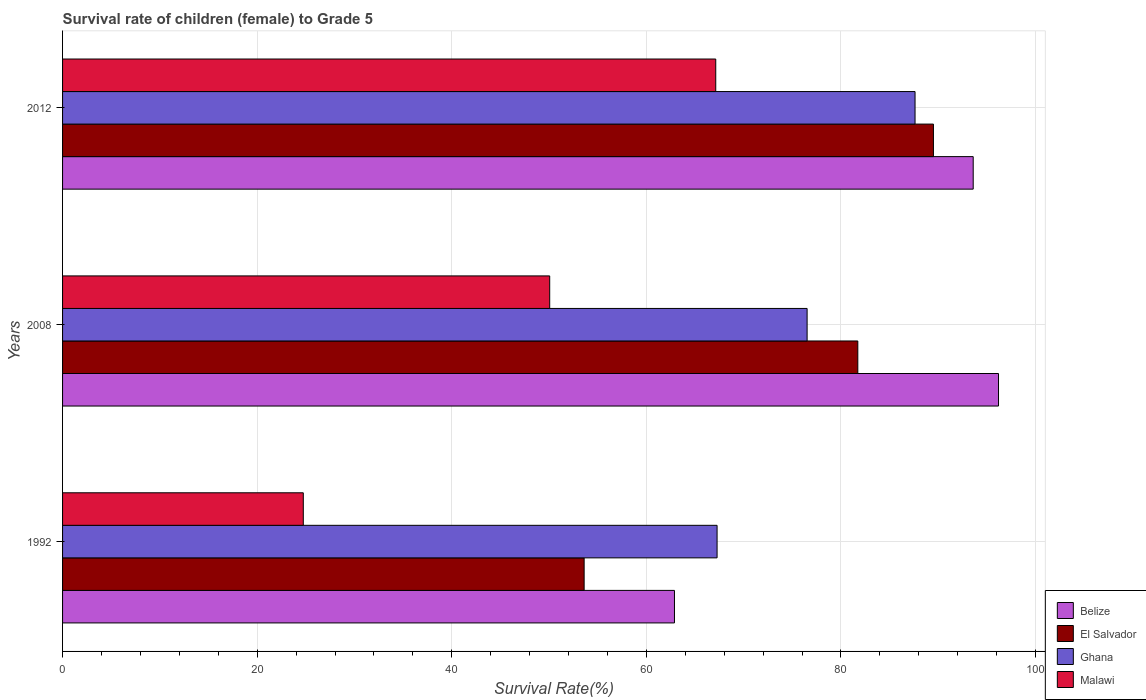How many groups of bars are there?
Your answer should be very brief. 3. In how many cases, is the number of bars for a given year not equal to the number of legend labels?
Make the answer very short. 0. What is the survival rate of female children to grade 5 in El Salvador in 2012?
Make the answer very short. 89.5. Across all years, what is the maximum survival rate of female children to grade 5 in Belize?
Your answer should be compact. 96.19. Across all years, what is the minimum survival rate of female children to grade 5 in Ghana?
Offer a very short reply. 67.27. In which year was the survival rate of female children to grade 5 in Malawi minimum?
Your response must be concise. 1992. What is the total survival rate of female children to grade 5 in El Salvador in the graph?
Offer a terse response. 224.84. What is the difference between the survival rate of female children to grade 5 in El Salvador in 1992 and that in 2008?
Provide a succinct answer. -28.13. What is the difference between the survival rate of female children to grade 5 in Belize in 2008 and the survival rate of female children to grade 5 in Malawi in 2012?
Your response must be concise. 29.06. What is the average survival rate of female children to grade 5 in Malawi per year?
Provide a short and direct response. 47.31. In the year 2012, what is the difference between the survival rate of female children to grade 5 in Ghana and survival rate of female children to grade 5 in Belize?
Provide a short and direct response. -5.98. In how many years, is the survival rate of female children to grade 5 in Belize greater than 80 %?
Your answer should be very brief. 2. What is the ratio of the survival rate of female children to grade 5 in El Salvador in 1992 to that in 2012?
Provide a succinct answer. 0.6. Is the survival rate of female children to grade 5 in El Salvador in 2008 less than that in 2012?
Provide a short and direct response. Yes. What is the difference between the highest and the second highest survival rate of female children to grade 5 in Belize?
Keep it short and to the point. 2.6. What is the difference between the highest and the lowest survival rate of female children to grade 5 in Ghana?
Give a very brief answer. 20.35. In how many years, is the survival rate of female children to grade 5 in Belize greater than the average survival rate of female children to grade 5 in Belize taken over all years?
Offer a terse response. 2. What does the 4th bar from the top in 2008 represents?
Give a very brief answer. Belize. What does the 4th bar from the bottom in 2012 represents?
Your response must be concise. Malawi. How many years are there in the graph?
Give a very brief answer. 3. Are the values on the major ticks of X-axis written in scientific E-notation?
Ensure brevity in your answer.  No. Where does the legend appear in the graph?
Offer a terse response. Bottom right. What is the title of the graph?
Your answer should be compact. Survival rate of children (female) to Grade 5. Does "Saudi Arabia" appear as one of the legend labels in the graph?
Make the answer very short. No. What is the label or title of the X-axis?
Your response must be concise. Survival Rate(%). What is the label or title of the Y-axis?
Your response must be concise. Years. What is the Survival Rate(%) in Belize in 1992?
Provide a succinct answer. 62.89. What is the Survival Rate(%) of El Salvador in 1992?
Give a very brief answer. 53.6. What is the Survival Rate(%) in Ghana in 1992?
Provide a succinct answer. 67.27. What is the Survival Rate(%) of Malawi in 1992?
Keep it short and to the point. 24.74. What is the Survival Rate(%) in Belize in 2008?
Your response must be concise. 96.19. What is the Survival Rate(%) in El Salvador in 2008?
Provide a short and direct response. 81.73. What is the Survival Rate(%) of Ghana in 2008?
Provide a short and direct response. 76.52. What is the Survival Rate(%) in Malawi in 2008?
Offer a very short reply. 50.07. What is the Survival Rate(%) of Belize in 2012?
Make the answer very short. 93.59. What is the Survival Rate(%) of El Salvador in 2012?
Your answer should be very brief. 89.5. What is the Survival Rate(%) in Ghana in 2012?
Your answer should be very brief. 87.61. What is the Survival Rate(%) in Malawi in 2012?
Your response must be concise. 67.13. Across all years, what is the maximum Survival Rate(%) in Belize?
Give a very brief answer. 96.19. Across all years, what is the maximum Survival Rate(%) of El Salvador?
Ensure brevity in your answer.  89.5. Across all years, what is the maximum Survival Rate(%) of Ghana?
Your response must be concise. 87.61. Across all years, what is the maximum Survival Rate(%) of Malawi?
Offer a terse response. 67.13. Across all years, what is the minimum Survival Rate(%) in Belize?
Give a very brief answer. 62.89. Across all years, what is the minimum Survival Rate(%) in El Salvador?
Provide a succinct answer. 53.6. Across all years, what is the minimum Survival Rate(%) of Ghana?
Your answer should be very brief. 67.27. Across all years, what is the minimum Survival Rate(%) of Malawi?
Your response must be concise. 24.74. What is the total Survival Rate(%) of Belize in the graph?
Ensure brevity in your answer.  252.67. What is the total Survival Rate(%) of El Salvador in the graph?
Make the answer very short. 224.84. What is the total Survival Rate(%) of Ghana in the graph?
Keep it short and to the point. 231.4. What is the total Survival Rate(%) of Malawi in the graph?
Your answer should be very brief. 141.94. What is the difference between the Survival Rate(%) of Belize in 1992 and that in 2008?
Ensure brevity in your answer.  -33.3. What is the difference between the Survival Rate(%) of El Salvador in 1992 and that in 2008?
Offer a very short reply. -28.13. What is the difference between the Survival Rate(%) of Ghana in 1992 and that in 2008?
Give a very brief answer. -9.25. What is the difference between the Survival Rate(%) in Malawi in 1992 and that in 2008?
Your response must be concise. -25.32. What is the difference between the Survival Rate(%) in Belize in 1992 and that in 2012?
Make the answer very short. -30.7. What is the difference between the Survival Rate(%) of El Salvador in 1992 and that in 2012?
Offer a terse response. -35.9. What is the difference between the Survival Rate(%) of Ghana in 1992 and that in 2012?
Keep it short and to the point. -20.35. What is the difference between the Survival Rate(%) in Malawi in 1992 and that in 2012?
Keep it short and to the point. -42.39. What is the difference between the Survival Rate(%) of Belize in 2008 and that in 2012?
Your response must be concise. 2.6. What is the difference between the Survival Rate(%) in El Salvador in 2008 and that in 2012?
Offer a terse response. -7.77. What is the difference between the Survival Rate(%) of Ghana in 2008 and that in 2012?
Keep it short and to the point. -11.09. What is the difference between the Survival Rate(%) in Malawi in 2008 and that in 2012?
Provide a short and direct response. -17.07. What is the difference between the Survival Rate(%) in Belize in 1992 and the Survival Rate(%) in El Salvador in 2008?
Offer a very short reply. -18.84. What is the difference between the Survival Rate(%) in Belize in 1992 and the Survival Rate(%) in Ghana in 2008?
Offer a very short reply. -13.63. What is the difference between the Survival Rate(%) in Belize in 1992 and the Survival Rate(%) in Malawi in 2008?
Provide a short and direct response. 12.82. What is the difference between the Survival Rate(%) in El Salvador in 1992 and the Survival Rate(%) in Ghana in 2008?
Your answer should be very brief. -22.92. What is the difference between the Survival Rate(%) in El Salvador in 1992 and the Survival Rate(%) in Malawi in 2008?
Your answer should be very brief. 3.54. What is the difference between the Survival Rate(%) in Ghana in 1992 and the Survival Rate(%) in Malawi in 2008?
Your response must be concise. 17.2. What is the difference between the Survival Rate(%) of Belize in 1992 and the Survival Rate(%) of El Salvador in 2012?
Your response must be concise. -26.61. What is the difference between the Survival Rate(%) in Belize in 1992 and the Survival Rate(%) in Ghana in 2012?
Provide a succinct answer. -24.72. What is the difference between the Survival Rate(%) of Belize in 1992 and the Survival Rate(%) of Malawi in 2012?
Offer a terse response. -4.24. What is the difference between the Survival Rate(%) of El Salvador in 1992 and the Survival Rate(%) of Ghana in 2012?
Offer a very short reply. -34.01. What is the difference between the Survival Rate(%) of El Salvador in 1992 and the Survival Rate(%) of Malawi in 2012?
Your answer should be very brief. -13.53. What is the difference between the Survival Rate(%) of Ghana in 1992 and the Survival Rate(%) of Malawi in 2012?
Ensure brevity in your answer.  0.14. What is the difference between the Survival Rate(%) of Belize in 2008 and the Survival Rate(%) of El Salvador in 2012?
Your answer should be very brief. 6.69. What is the difference between the Survival Rate(%) of Belize in 2008 and the Survival Rate(%) of Ghana in 2012?
Your answer should be very brief. 8.58. What is the difference between the Survival Rate(%) of Belize in 2008 and the Survival Rate(%) of Malawi in 2012?
Ensure brevity in your answer.  29.06. What is the difference between the Survival Rate(%) in El Salvador in 2008 and the Survival Rate(%) in Ghana in 2012?
Give a very brief answer. -5.88. What is the difference between the Survival Rate(%) in El Salvador in 2008 and the Survival Rate(%) in Malawi in 2012?
Provide a succinct answer. 14.6. What is the difference between the Survival Rate(%) of Ghana in 2008 and the Survival Rate(%) of Malawi in 2012?
Your answer should be compact. 9.39. What is the average Survival Rate(%) in Belize per year?
Offer a terse response. 84.22. What is the average Survival Rate(%) of El Salvador per year?
Ensure brevity in your answer.  74.95. What is the average Survival Rate(%) of Ghana per year?
Your answer should be compact. 77.13. What is the average Survival Rate(%) of Malawi per year?
Your answer should be compact. 47.31. In the year 1992, what is the difference between the Survival Rate(%) of Belize and Survival Rate(%) of El Salvador?
Provide a succinct answer. 9.28. In the year 1992, what is the difference between the Survival Rate(%) in Belize and Survival Rate(%) in Ghana?
Your response must be concise. -4.38. In the year 1992, what is the difference between the Survival Rate(%) in Belize and Survival Rate(%) in Malawi?
Make the answer very short. 38.15. In the year 1992, what is the difference between the Survival Rate(%) in El Salvador and Survival Rate(%) in Ghana?
Make the answer very short. -13.66. In the year 1992, what is the difference between the Survival Rate(%) of El Salvador and Survival Rate(%) of Malawi?
Offer a terse response. 28.86. In the year 1992, what is the difference between the Survival Rate(%) of Ghana and Survival Rate(%) of Malawi?
Ensure brevity in your answer.  42.53. In the year 2008, what is the difference between the Survival Rate(%) in Belize and Survival Rate(%) in El Salvador?
Ensure brevity in your answer.  14.46. In the year 2008, what is the difference between the Survival Rate(%) in Belize and Survival Rate(%) in Ghana?
Your answer should be very brief. 19.67. In the year 2008, what is the difference between the Survival Rate(%) in Belize and Survival Rate(%) in Malawi?
Give a very brief answer. 46.13. In the year 2008, what is the difference between the Survival Rate(%) in El Salvador and Survival Rate(%) in Ghana?
Your answer should be very brief. 5.21. In the year 2008, what is the difference between the Survival Rate(%) of El Salvador and Survival Rate(%) of Malawi?
Your answer should be compact. 31.67. In the year 2008, what is the difference between the Survival Rate(%) in Ghana and Survival Rate(%) in Malawi?
Your answer should be very brief. 26.46. In the year 2012, what is the difference between the Survival Rate(%) of Belize and Survival Rate(%) of El Salvador?
Keep it short and to the point. 4.09. In the year 2012, what is the difference between the Survival Rate(%) in Belize and Survival Rate(%) in Ghana?
Provide a succinct answer. 5.98. In the year 2012, what is the difference between the Survival Rate(%) in Belize and Survival Rate(%) in Malawi?
Provide a succinct answer. 26.46. In the year 2012, what is the difference between the Survival Rate(%) of El Salvador and Survival Rate(%) of Ghana?
Make the answer very short. 1.89. In the year 2012, what is the difference between the Survival Rate(%) of El Salvador and Survival Rate(%) of Malawi?
Make the answer very short. 22.37. In the year 2012, what is the difference between the Survival Rate(%) of Ghana and Survival Rate(%) of Malawi?
Your response must be concise. 20.48. What is the ratio of the Survival Rate(%) in Belize in 1992 to that in 2008?
Your response must be concise. 0.65. What is the ratio of the Survival Rate(%) in El Salvador in 1992 to that in 2008?
Give a very brief answer. 0.66. What is the ratio of the Survival Rate(%) of Ghana in 1992 to that in 2008?
Offer a very short reply. 0.88. What is the ratio of the Survival Rate(%) in Malawi in 1992 to that in 2008?
Offer a very short reply. 0.49. What is the ratio of the Survival Rate(%) in Belize in 1992 to that in 2012?
Make the answer very short. 0.67. What is the ratio of the Survival Rate(%) of El Salvador in 1992 to that in 2012?
Make the answer very short. 0.6. What is the ratio of the Survival Rate(%) in Ghana in 1992 to that in 2012?
Keep it short and to the point. 0.77. What is the ratio of the Survival Rate(%) of Malawi in 1992 to that in 2012?
Your answer should be compact. 0.37. What is the ratio of the Survival Rate(%) in Belize in 2008 to that in 2012?
Keep it short and to the point. 1.03. What is the ratio of the Survival Rate(%) in El Salvador in 2008 to that in 2012?
Your response must be concise. 0.91. What is the ratio of the Survival Rate(%) of Ghana in 2008 to that in 2012?
Keep it short and to the point. 0.87. What is the ratio of the Survival Rate(%) in Malawi in 2008 to that in 2012?
Provide a short and direct response. 0.75. What is the difference between the highest and the second highest Survival Rate(%) in Belize?
Provide a short and direct response. 2.6. What is the difference between the highest and the second highest Survival Rate(%) in El Salvador?
Give a very brief answer. 7.77. What is the difference between the highest and the second highest Survival Rate(%) of Ghana?
Your response must be concise. 11.09. What is the difference between the highest and the second highest Survival Rate(%) in Malawi?
Your answer should be very brief. 17.07. What is the difference between the highest and the lowest Survival Rate(%) in Belize?
Your answer should be compact. 33.3. What is the difference between the highest and the lowest Survival Rate(%) of El Salvador?
Offer a terse response. 35.9. What is the difference between the highest and the lowest Survival Rate(%) in Ghana?
Offer a very short reply. 20.35. What is the difference between the highest and the lowest Survival Rate(%) of Malawi?
Your response must be concise. 42.39. 